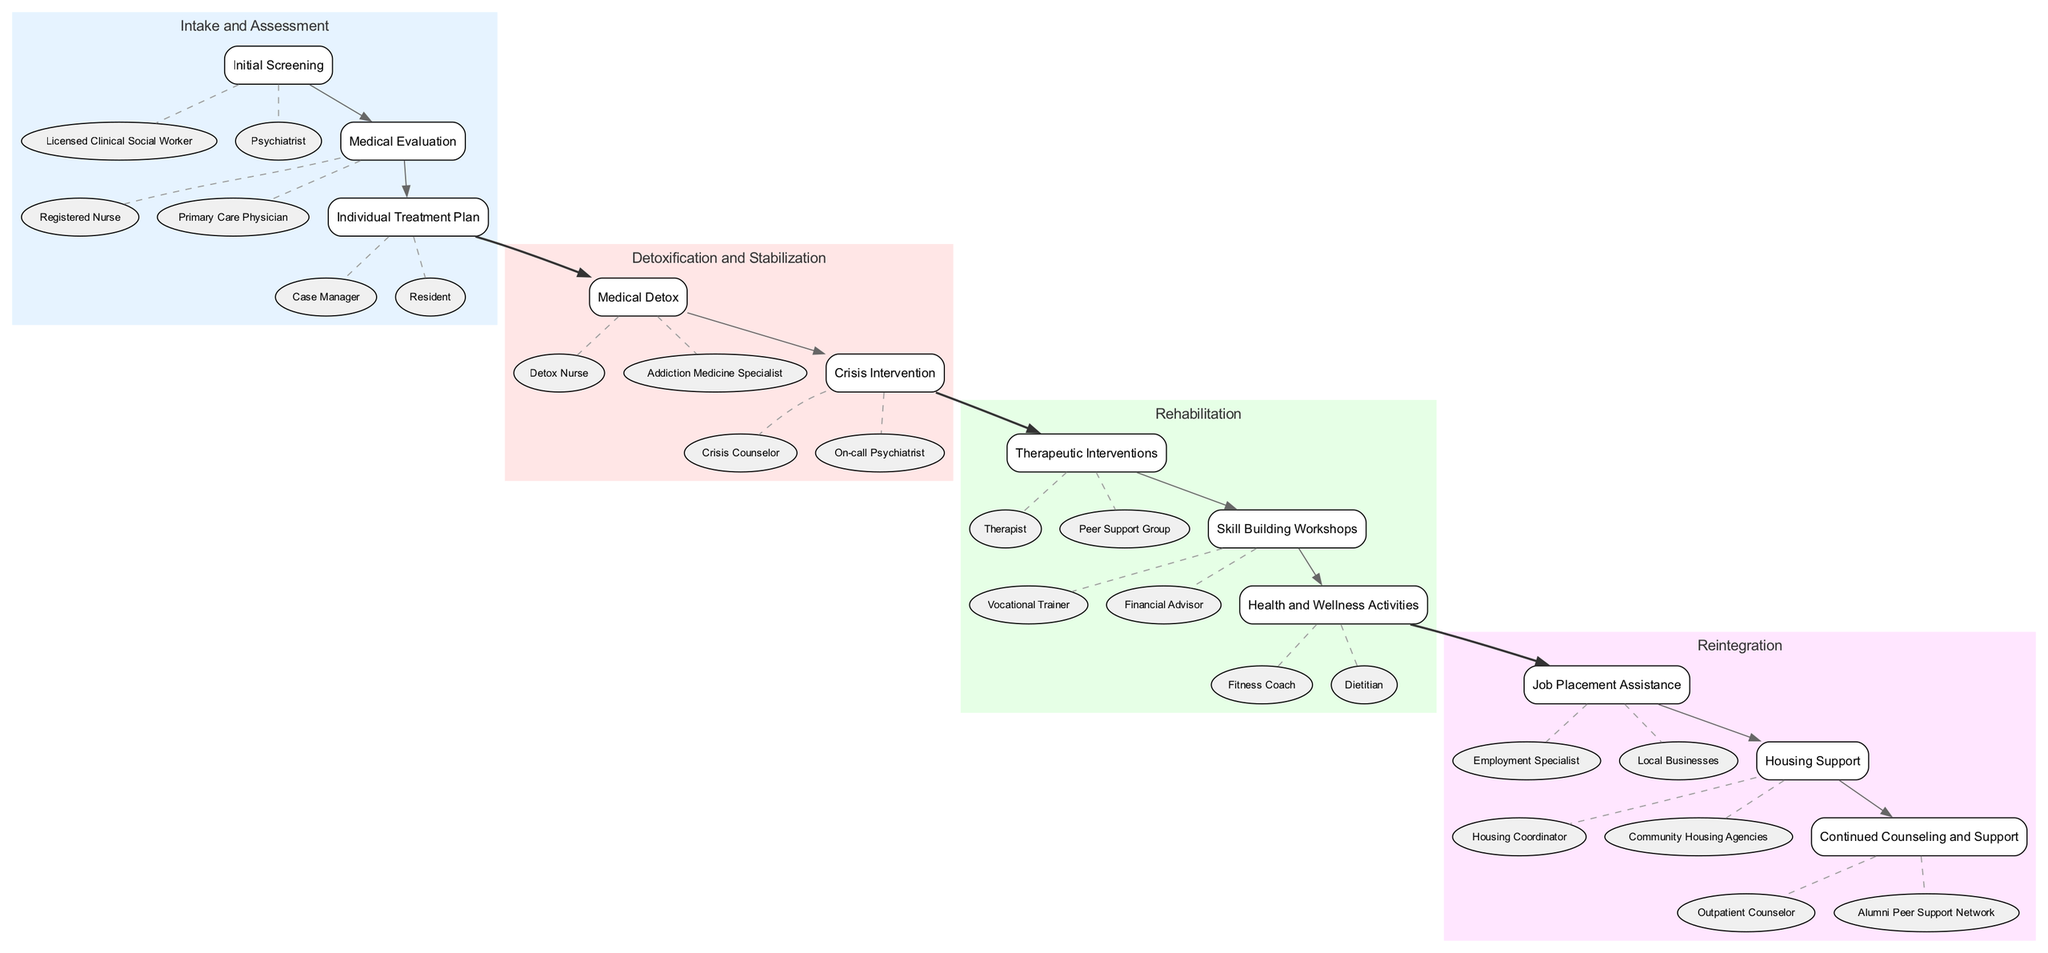What are the three phases listed in the clinical pathway? The diagram includes the phases: Intake and Assessment, Detoxification and Stabilization, Rehabilitation, and Reintegration. Each of these phases is clearly labeled in the corresponding colored boxes.
Answer: Intake and Assessment, Detoxification and Stabilization, Rehabilitation, Reintegration How many elements are in the Rehabilitation phase? Under the Rehabilitation phase, there are three elements listed: Therapeutic Interventions, Skill Building Workshops, and Health and Wellness Activities. This is determined by counting the elements within the corresponding phase box.
Answer: 3 Which element is associated with job searching support? The element associated with job searching support is "Job Placement Assistance," identified within the Reintegration phase. Consulting the listed elements under this phase confirms its presence.
Answer: Job Placement Assistance What is the description of the Medical Detox element? The Medical Detox element's description states it provides "Supervised detoxification to manage withdrawal symptoms." This is taken directly from the tooltip of this particular element in the diagram.
Answer: Supervised detoxification to manage withdrawal symptoms Who is primarily responsible for creating the Individual Treatment Plan? The primary responsibility for creating the Individual Treatment Plan falls to the "Case Manager," as indicated in the Intake and Assessment phase next to that element.
Answer: Case Manager What type of activities does Health and Wellness Activities include? Health and Wellness Activities include programs promoting physical well-being, specifically exercise and nutrition classes, as detailed in the description of that element.
Answer: Physical well-being, exercise and nutrition classes How does the Detoxification and Stabilization phase connect to the Rehabilitation phase? The connection is illustrated by a solid line from the last element of Detoxification and Stabilization to the first element of Rehabilitation, indicating a direct flow between these two phases in the pathway.
Answer: Direct flow Which professional is involved in the Medical Evaluation? The Medical Evaluation involves a "Registered Nurse" and a "Primary Care Physician," as these entities are listed alongside that element in the diagram.
Answer: Registered Nurse, Primary Care Physician How many entities are listed for the Skill Building Workshops? The Skill Building Workshops lists two entities: "Vocational Trainer" and "Financial Advisor." This is noted by inspecting the elements under the Rehabilitation phase for the specified workshop.
Answer: 2 